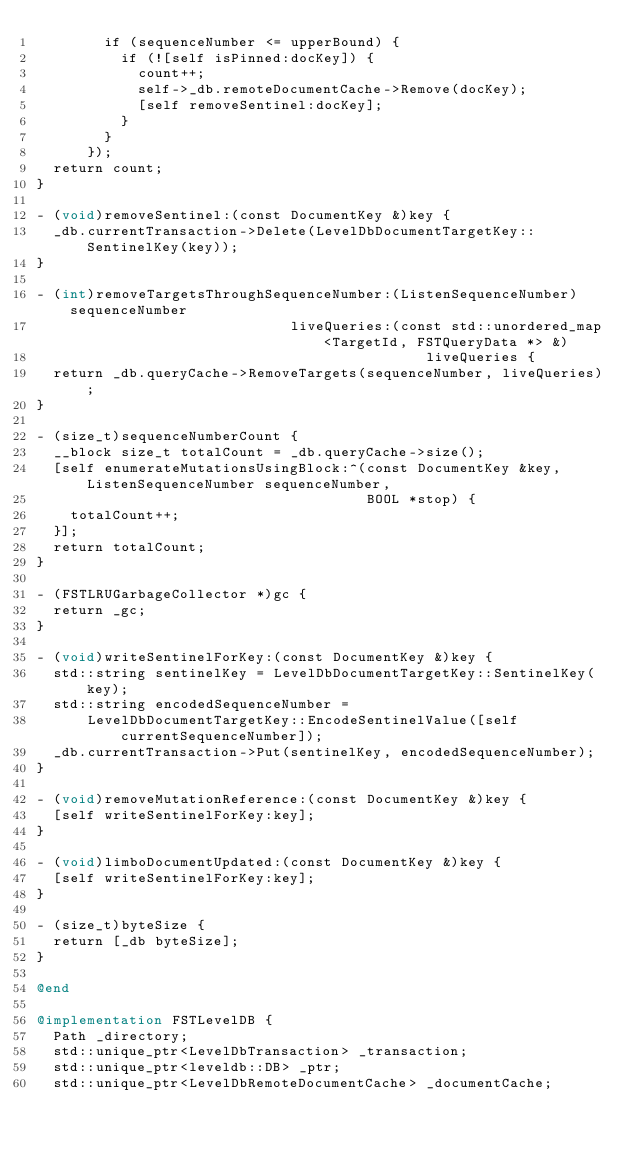<code> <loc_0><loc_0><loc_500><loc_500><_ObjectiveC_>        if (sequenceNumber <= upperBound) {
          if (![self isPinned:docKey]) {
            count++;
            self->_db.remoteDocumentCache->Remove(docKey);
            [self removeSentinel:docKey];
          }
        }
      });
  return count;
}

- (void)removeSentinel:(const DocumentKey &)key {
  _db.currentTransaction->Delete(LevelDbDocumentTargetKey::SentinelKey(key));
}

- (int)removeTargetsThroughSequenceNumber:(ListenSequenceNumber)sequenceNumber
                              liveQueries:(const std::unordered_map<TargetId, FSTQueryData *> &)
                                              liveQueries {
  return _db.queryCache->RemoveTargets(sequenceNumber, liveQueries);
}

- (size_t)sequenceNumberCount {
  __block size_t totalCount = _db.queryCache->size();
  [self enumerateMutationsUsingBlock:^(const DocumentKey &key, ListenSequenceNumber sequenceNumber,
                                       BOOL *stop) {
    totalCount++;
  }];
  return totalCount;
}

- (FSTLRUGarbageCollector *)gc {
  return _gc;
}

- (void)writeSentinelForKey:(const DocumentKey &)key {
  std::string sentinelKey = LevelDbDocumentTargetKey::SentinelKey(key);
  std::string encodedSequenceNumber =
      LevelDbDocumentTargetKey::EncodeSentinelValue([self currentSequenceNumber]);
  _db.currentTransaction->Put(sentinelKey, encodedSequenceNumber);
}

- (void)removeMutationReference:(const DocumentKey &)key {
  [self writeSentinelForKey:key];
}

- (void)limboDocumentUpdated:(const DocumentKey &)key {
  [self writeSentinelForKey:key];
}

- (size_t)byteSize {
  return [_db byteSize];
}

@end

@implementation FSTLevelDB {
  Path _directory;
  std::unique_ptr<LevelDbTransaction> _transaction;
  std::unique_ptr<leveldb::DB> _ptr;
  std::unique_ptr<LevelDbRemoteDocumentCache> _documentCache;</code> 